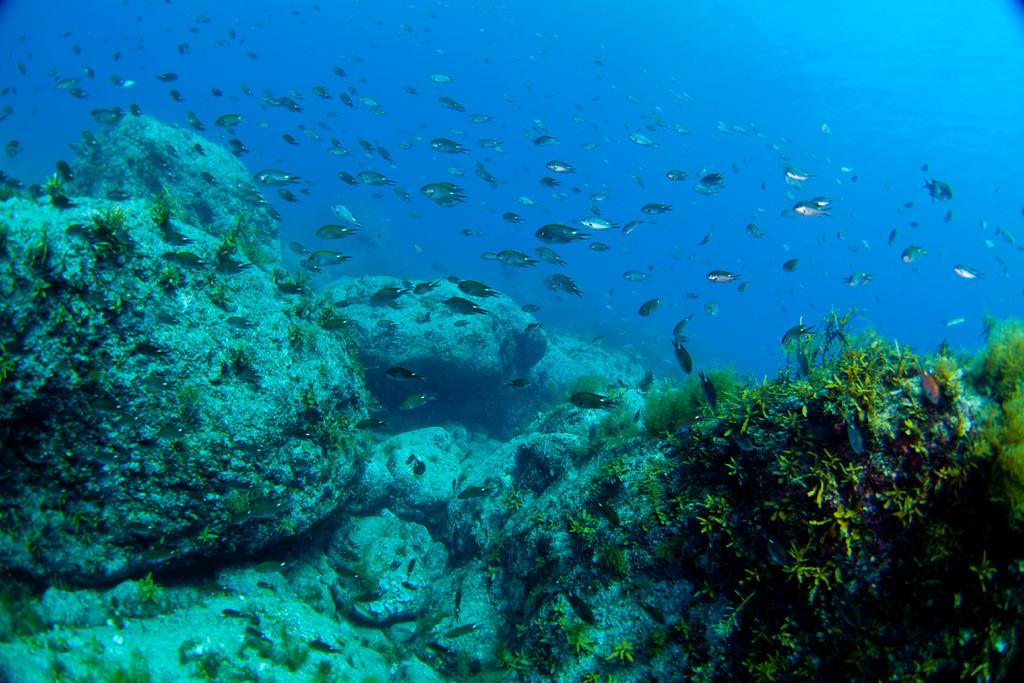What type of animals can be seen in the image? There are fishes in the water in the image. What other elements can be seen in the image besides the fishes? There are rocks and grass visible in the image. What type of reward can be seen hanging from the rocks in the image? There is no reward present in the image; it features fishes in the water, rocks, and grass. 